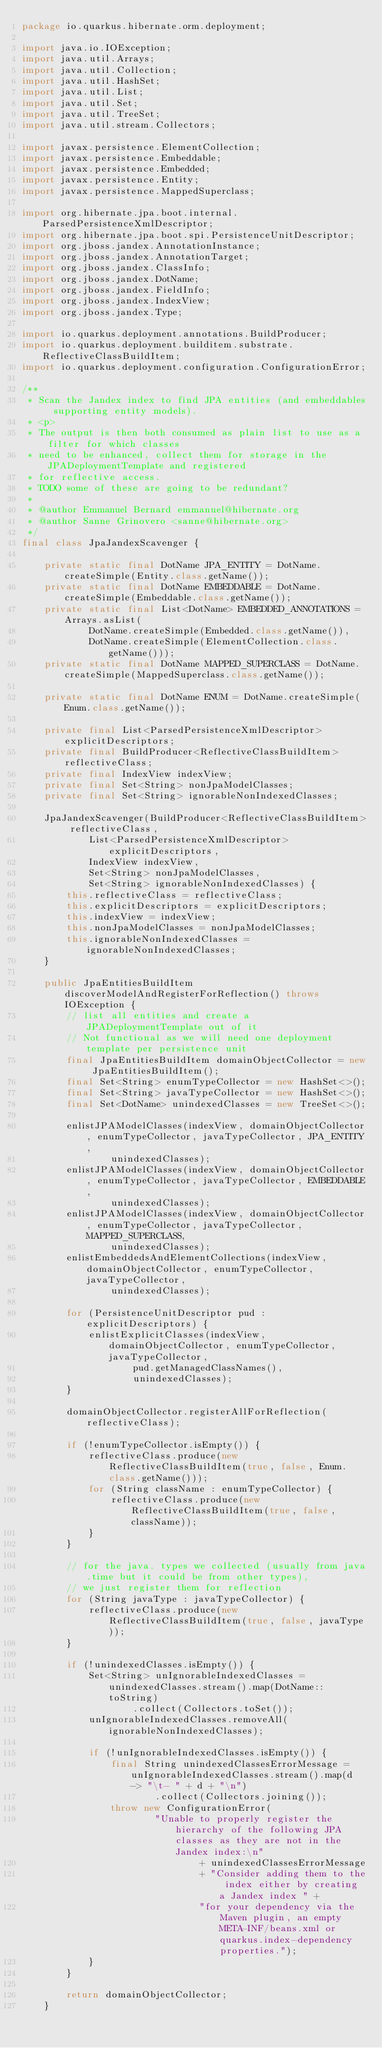Convert code to text. <code><loc_0><loc_0><loc_500><loc_500><_Java_>package io.quarkus.hibernate.orm.deployment;

import java.io.IOException;
import java.util.Arrays;
import java.util.Collection;
import java.util.HashSet;
import java.util.List;
import java.util.Set;
import java.util.TreeSet;
import java.util.stream.Collectors;

import javax.persistence.ElementCollection;
import javax.persistence.Embeddable;
import javax.persistence.Embedded;
import javax.persistence.Entity;
import javax.persistence.MappedSuperclass;

import org.hibernate.jpa.boot.internal.ParsedPersistenceXmlDescriptor;
import org.hibernate.jpa.boot.spi.PersistenceUnitDescriptor;
import org.jboss.jandex.AnnotationInstance;
import org.jboss.jandex.AnnotationTarget;
import org.jboss.jandex.ClassInfo;
import org.jboss.jandex.DotName;
import org.jboss.jandex.FieldInfo;
import org.jboss.jandex.IndexView;
import org.jboss.jandex.Type;

import io.quarkus.deployment.annotations.BuildProducer;
import io.quarkus.deployment.builditem.substrate.ReflectiveClassBuildItem;
import io.quarkus.deployment.configuration.ConfigurationError;

/**
 * Scan the Jandex index to find JPA entities (and embeddables supporting entity models).
 * <p>
 * The output is then both consumed as plain list to use as a filter for which classes
 * need to be enhanced, collect them for storage in the JPADeploymentTemplate and registered
 * for reflective access.
 * TODO some of these are going to be redundant?
 *
 * @author Emmanuel Bernard emmanuel@hibernate.org
 * @author Sanne Grinovero <sanne@hibernate.org>
 */
final class JpaJandexScavenger {

    private static final DotName JPA_ENTITY = DotName.createSimple(Entity.class.getName());
    private static final DotName EMBEDDABLE = DotName.createSimple(Embeddable.class.getName());
    private static final List<DotName> EMBEDDED_ANNOTATIONS = Arrays.asList(
            DotName.createSimple(Embedded.class.getName()),
            DotName.createSimple(ElementCollection.class.getName()));
    private static final DotName MAPPED_SUPERCLASS = DotName.createSimple(MappedSuperclass.class.getName());

    private static final DotName ENUM = DotName.createSimple(Enum.class.getName());

    private final List<ParsedPersistenceXmlDescriptor> explicitDescriptors;
    private final BuildProducer<ReflectiveClassBuildItem> reflectiveClass;
    private final IndexView indexView;
    private final Set<String> nonJpaModelClasses;
    private final Set<String> ignorableNonIndexedClasses;

    JpaJandexScavenger(BuildProducer<ReflectiveClassBuildItem> reflectiveClass,
            List<ParsedPersistenceXmlDescriptor> explicitDescriptors,
            IndexView indexView,
            Set<String> nonJpaModelClasses,
            Set<String> ignorableNonIndexedClasses) {
        this.reflectiveClass = reflectiveClass;
        this.explicitDescriptors = explicitDescriptors;
        this.indexView = indexView;
        this.nonJpaModelClasses = nonJpaModelClasses;
        this.ignorableNonIndexedClasses = ignorableNonIndexedClasses;
    }

    public JpaEntitiesBuildItem discoverModelAndRegisterForReflection() throws IOException {
        // list all entities and create a JPADeploymentTemplate out of it
        // Not functional as we will need one deployment template per persistence unit
        final JpaEntitiesBuildItem domainObjectCollector = new JpaEntitiesBuildItem();
        final Set<String> enumTypeCollector = new HashSet<>();
        final Set<String> javaTypeCollector = new HashSet<>();
        final Set<DotName> unindexedClasses = new TreeSet<>();

        enlistJPAModelClasses(indexView, domainObjectCollector, enumTypeCollector, javaTypeCollector, JPA_ENTITY,
                unindexedClasses);
        enlistJPAModelClasses(indexView, domainObjectCollector, enumTypeCollector, javaTypeCollector, EMBEDDABLE,
                unindexedClasses);
        enlistJPAModelClasses(indexView, domainObjectCollector, enumTypeCollector, javaTypeCollector, MAPPED_SUPERCLASS,
                unindexedClasses);
        enlistEmbeddedsAndElementCollections(indexView, domainObjectCollector, enumTypeCollector, javaTypeCollector,
                unindexedClasses);

        for (PersistenceUnitDescriptor pud : explicitDescriptors) {
            enlistExplicitClasses(indexView, domainObjectCollector, enumTypeCollector, javaTypeCollector,
                    pud.getManagedClassNames(),
                    unindexedClasses);
        }

        domainObjectCollector.registerAllForReflection(reflectiveClass);

        if (!enumTypeCollector.isEmpty()) {
            reflectiveClass.produce(new ReflectiveClassBuildItem(true, false, Enum.class.getName()));
            for (String className : enumTypeCollector) {
                reflectiveClass.produce(new ReflectiveClassBuildItem(true, false, className));
            }
        }

        // for the java. types we collected (usually from java.time but it could be from other types),
        // we just register them for reflection
        for (String javaType : javaTypeCollector) {
            reflectiveClass.produce(new ReflectiveClassBuildItem(true, false, javaType));
        }

        if (!unindexedClasses.isEmpty()) {
            Set<String> unIgnorableIndexedClasses = unindexedClasses.stream().map(DotName::toString)
                    .collect(Collectors.toSet());
            unIgnorableIndexedClasses.removeAll(ignorableNonIndexedClasses);

            if (!unIgnorableIndexedClasses.isEmpty()) {
                final String unindexedClassesErrorMessage = unIgnorableIndexedClasses.stream().map(d -> "\t- " + d + "\n")
                        .collect(Collectors.joining());
                throw new ConfigurationError(
                        "Unable to properly register the hierarchy of the following JPA classes as they are not in the Jandex index:\n"
                                + unindexedClassesErrorMessage
                                + "Consider adding them to the index either by creating a Jandex index " +
                                "for your dependency via the Maven plugin, an empty META-INF/beans.xml or quarkus.index-dependency properties.");
            }
        }

        return domainObjectCollector;
    }
</code> 